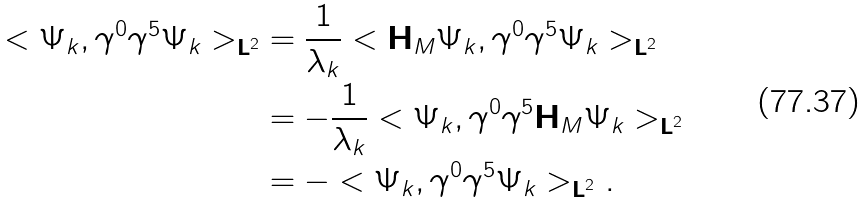Convert formula to latex. <formula><loc_0><loc_0><loc_500><loc_500>< \Psi _ { k } , \gamma ^ { 0 } \gamma ^ { 5 } \Psi _ { k } > _ { \mathbf L ^ { 2 } } & = \frac { 1 } { \lambda _ { k } } < \mathbf H _ { M } \Psi _ { k } , \gamma ^ { 0 } \gamma ^ { 5 } \Psi _ { k } > _ { \mathbf L ^ { 2 } } \\ & = - \frac { 1 } { \lambda _ { k } } < \Psi _ { k } , \gamma ^ { 0 } \gamma ^ { 5 } \mathbf H _ { M } \Psi _ { k } > _ { \mathbf L ^ { 2 } } \\ & = - < \Psi _ { k } , \gamma ^ { 0 } \gamma ^ { 5 } \Psi _ { k } > _ { \mathbf L ^ { 2 } } .</formula> 